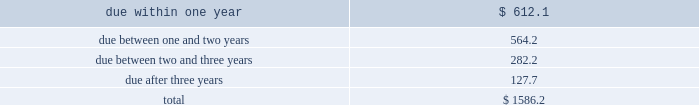Table of contents totaled an absolute notional equivalent of $ 292.3 million and $ 190.5 million , respectively , with the year-over-year increase primarily driven by earnings growth .
At this time , we do not hedge these long-term investment exposures .
We do not use foreign exchange contracts for speculative trading purposes , nor do we hedge our foreign currency exposure in a manner that entirely offsets the effects of changes in foreign exchange rates .
We regularly review our hedging program and assess the need to utilize financial instruments to hedge currency exposures on an ongoing basis .
Cash flow hedging 2014hedges of forecasted foreign currency revenue we may use foreign exchange purchased options or forward contracts to hedge foreign currency revenue denominated in euros , british pounds and japanese yen .
We hedge these cash flow exposures to reduce the risk that our earnings and cash flows will be adversely affected by changes in exchange rates .
These foreign exchange contracts , carried at fair value , may have maturities between one and twelve months .
We enter into these foreign exchange contracts to hedge forecasted revenue in the normal course of business and accordingly , they are not speculative in nature .
We record changes in the intrinsic value of these cash flow hedges in accumulated other comprehensive income ( loss ) until the forecasted transaction occurs .
When the forecasted transaction occurs , we reclassify the related gain or loss on the cash flow hedge to revenue .
In the event the underlying forecasted transaction does not occur , or it becomes probable that it will not occur , we reclassify the gain or loss on the related cash flow hedge from accumulated other comprehensive income ( loss ) to interest and other income , net on our consolidated statements of income at that time .
For the fiscal year ended november 30 , 2018 , there were no net gains or losses recognized in other income relating to hedges of forecasted transactions that did not occur .
Balance sheet hedging 2014hedging of foreign currency assets and liabilities we hedge exposures related to our net recognized foreign currency assets and liabilities with foreign exchange forward contracts to reduce the risk that our earnings and cash flows will be adversely affected by changes in foreign currency exchange rates .
These foreign exchange contracts are carried at fair value with changes in the fair value recorded as interest and other income , net .
These foreign exchange contracts do not subject us to material balance sheet risk due to exchange rate movements because gains and losses on these contracts are intended to offset gains and losses on the assets and liabilities being hedged .
At november 30 , 2018 , the outstanding balance sheet hedging derivatives had maturities of 180 days or less .
See note 5 of our notes to consolidated financial statements for information regarding our hedging activities .
Interest rate risk short-term investments and fixed income securities at november 30 , 2018 , we had debt securities classified as short-term investments of $ 1.59 billion .
Changes in interest rates could adversely affect the market value of these investments .
The table separates these investments , based on stated maturities , to show the approximate exposure to interest rates ( in millions ) : .
A sensitivity analysis was performed on our investment portfolio as of november 30 , 2018 .
The analysis is based on an estimate of the hypothetical changes in market value of the portfolio that would result from an immediate parallel shift in the yield curve of various magnitudes. .
What portion of the presented investments is due within 24 months? 
Computations: ((612.1 + 564.2) / 1586.2)
Answer: 0.74158. 